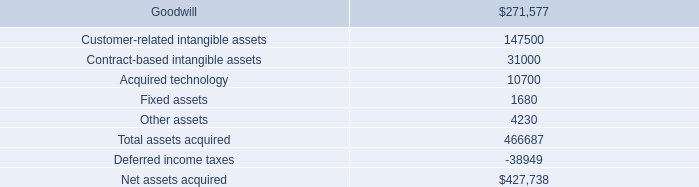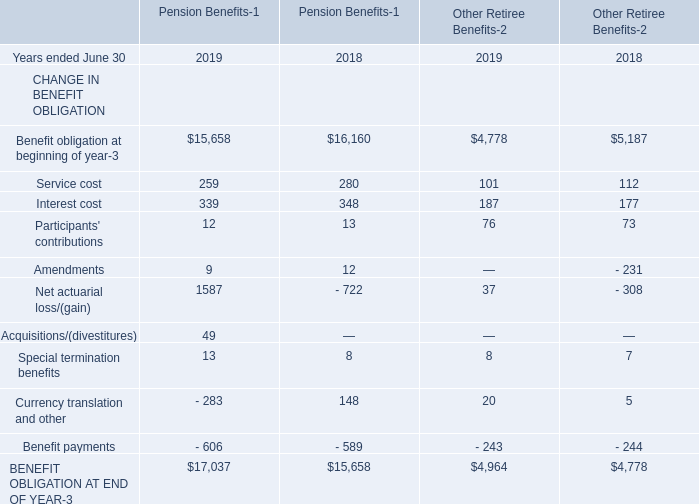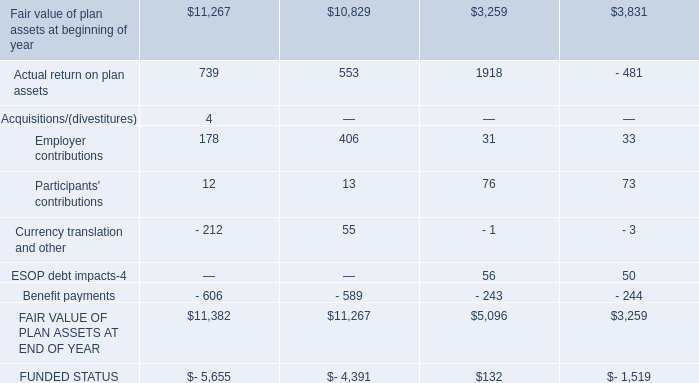what will be the yearly amortization expense related to acquired technology , ( in thousands ) ? 
Computations: (10700 / 7)
Answer: 1528.57143. What's the sum of FAIR VALUE OF PLAN ASSETS AT END OF YEAR, Benefit obligation at beginning of year of Pension Benefits 2019, and Fair value of plan assets at beginning of year ? 
Computations: ((5096.0 + 15658.0) + 10829.0)
Answer: 31583.0. 